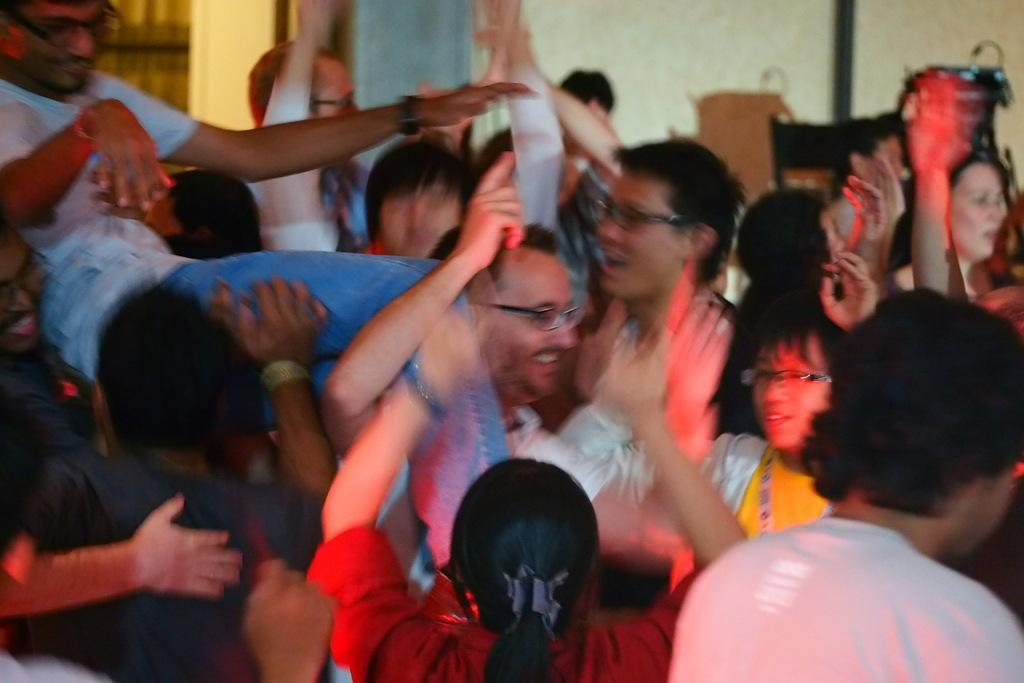In one or two sentences, can you explain what this image depicts? In this image people are standing on the floor. At the back side there is a wall. 